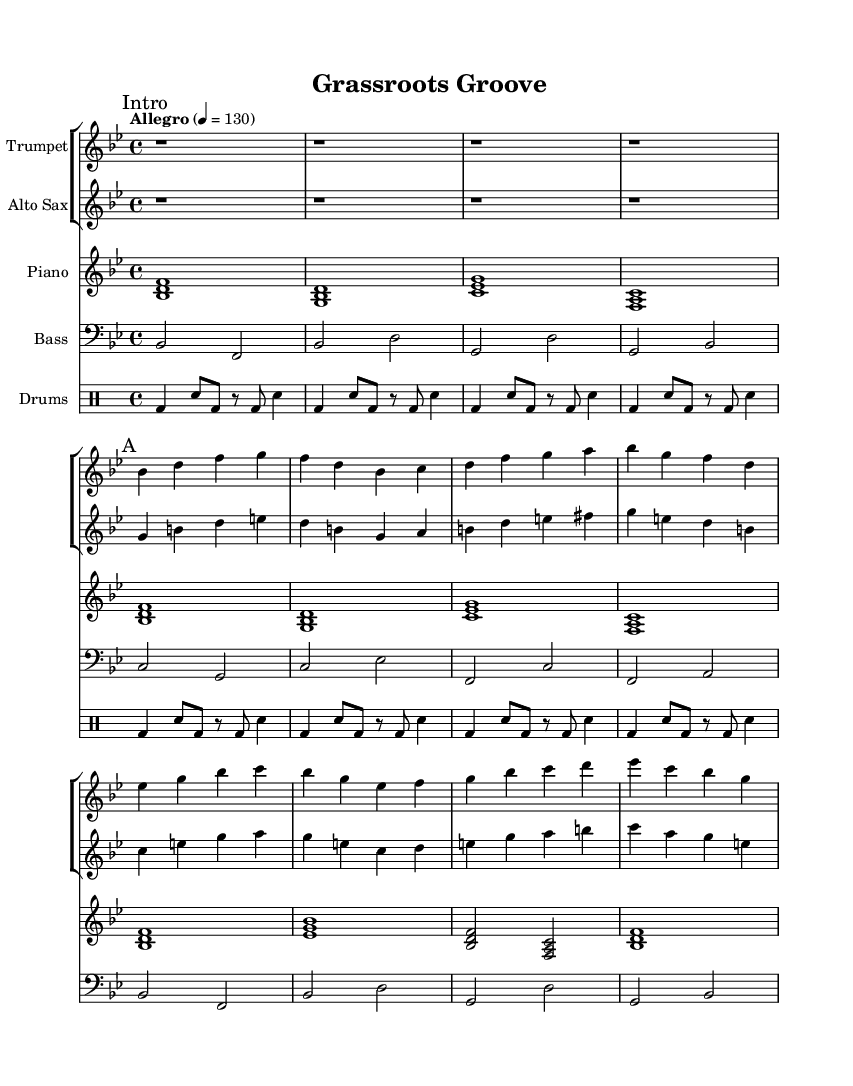What is the key signature of this music? The key signature indicates the presence of two flats, which corresponds to B flat major.
Answer: B flat major What is the time signature of this piece? The time signature is shown at the beginning of the sheet music, indicating that there are four beats per measure.
Answer: 4/4 What is the tempo marking of this piece? The tempo marking specifies the speed of the piece, stating it should be played at 130 beats per minute, described as Allegro.
Answer: Allegro, 130 How many measures are in the "A" section of this piece? The "A" section consists of the part marked with a single "A", which has 8 measures based on the musical notation.
Answer: 8 measures Which instruments are included in the big band arrangement of this piece? Reviewing the stave names on the score shows that the arrangement includes trumpet, alto sax, piano, bass, and drums.
Answer: Trumpet, Alto Sax, Piano, Bass, Drums What is the first note played by the alto saxophone in the "A" section? Looking at the first measure of the "A" section for the alto sax, the first note is G.
Answer: G How does the bass line vary compared to the piano's chord structure? Analyzing the bass line indicates that it plays single notes focusing on root tone while the piano plays chords outlining harmony and texture.
Answer: Bass plays single notes; Piano plays chords 